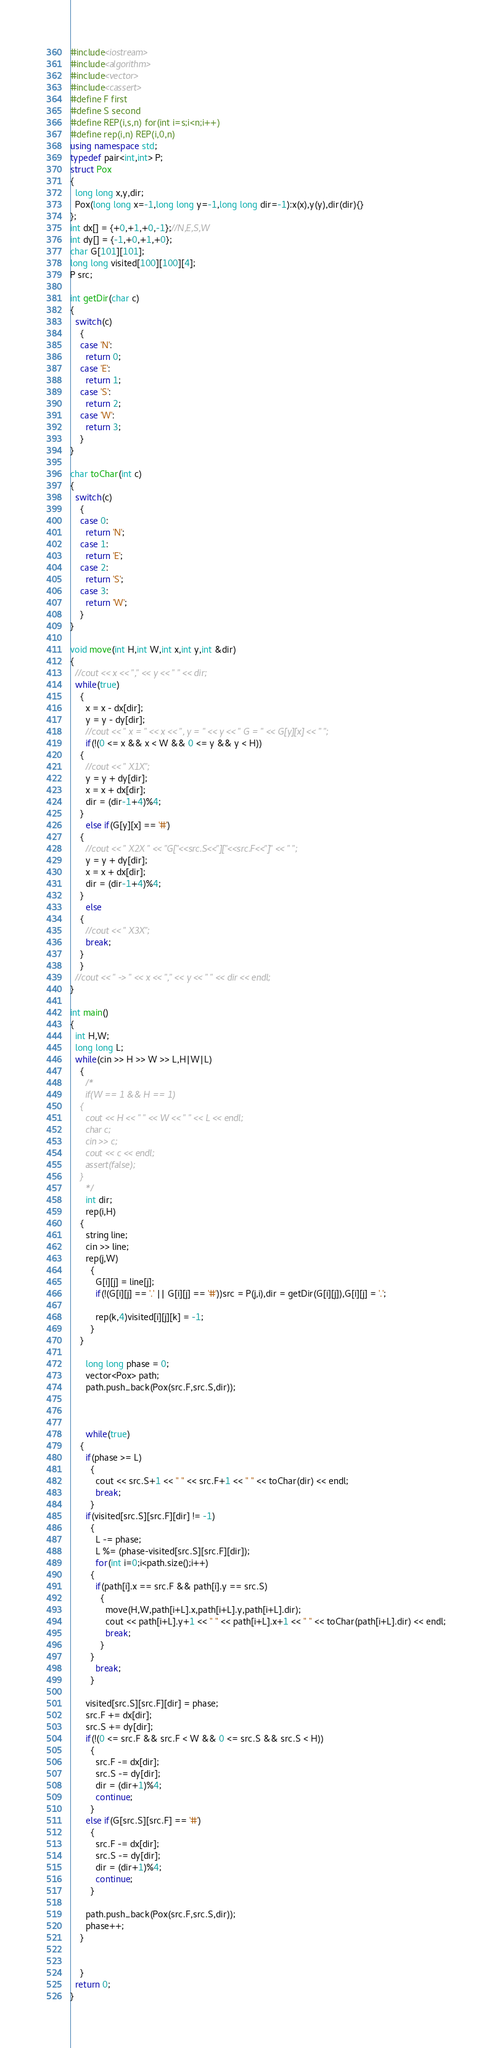Convert code to text. <code><loc_0><loc_0><loc_500><loc_500><_C++_>#include<iostream>
#include<algorithm>
#include<vector>
#include<cassert>
#define F first
#define S second
#define REP(i,s,n) for(int i=s;i<n;i++)
#define rep(i,n) REP(i,0,n)
using namespace std;
typedef pair<int,int> P;
struct Pox
{
  long long x,y,dir;
  Pox(long long x=-1,long long y=-1,long long dir=-1):x(x),y(y),dir(dir){}
};
int dx[] = {+0,+1,+0,-1};//N,E,S,W
int dy[] = {-1,+0,+1,+0};
char G[101][101];
long long visited[100][100][4];
P src;

int getDir(char c)
{
  switch(c)
    {
    case 'N':
      return 0;
    case 'E':
      return 1;
    case 'S':
      return 2;
    case 'W':
      return 3;
    }
}

char toChar(int c)
{
  switch(c)
    {
    case 0:
      return 'N';
    case 1:
      return 'E';
    case 2:
      return 'S';
    case 3:
      return 'W';
    }
}

void move(int H,int W,int x,int y,int &dir)
{
  //cout << x << "," << y << " " << dir;
  while(true)		
    {      
      x = x - dx[dir];
      y = y - dy[dir];
      //cout << " x = " << x << ", y = " << y << " G = " << G[y][x] << " ";
      if(!(0 <= x && x < W && 0 <= y && y < H))
	{
	  //cout << " X1X";
	  y = y + dy[dir];
	  x = x + dx[dir];
	  dir = (dir-1+4)%4;
	}
      else if(G[y][x] == '#')
	{
	  //cout << " X2X " << "G["<<src.S<<"]["<<src.F<<"]" << " ";
	  y = y + dy[dir];
	  x = x + dx[dir];
	  dir = (dir-1+4)%4;
	}
      else 
	{
	  //cout << " X3X";
	  break;
	}
    }
  //cout << " -> " << x << "," << y << " " << dir << endl;
}
 
int main()
{
  int H,W;
  long long L;
  while(cin >> H >> W >> L,H|W|L)
    {
      /*
      if(W == 1 && H == 1)
	{
	  cout << H << " " << W << " " << L << endl;
	  char c;
	  cin >> c;
	  cout << c << endl;
	  assert(false);
	}
      */
      int dir;
      rep(i,H)
	{
	  string line;
	  cin >> line;
	  rep(j,W)
	    {
	      G[i][j] = line[j];
	      if(!(G[i][j] == '.' || G[i][j] == '#'))src = P(j,i),dir = getDir(G[i][j]),G[i][j] = '.';
	      
	      rep(k,4)visited[i][j][k] = -1;
	    }
	}     

      long long phase = 0;
      vector<Pox> path;
      path.push_back(Pox(src.F,src.S,dir));
      


      while(true)
	{
	  if(phase >= L)
	    {
	      cout << src.S+1 << " " << src.F+1 << " " << toChar(dir) << endl;  
	      break;
	    }
	  if(visited[src.S][src.F][dir] != -1)
	    {   
	      L -= phase;
	      L %= (phase-visited[src.S][src.F][dir]);
	      for(int i=0;i<path.size();i++)
		{
		  if(path[i].x == src.F && path[i].y == src.S)
		    {
		      move(H,W,path[i+L].x,path[i+L].y,path[i+L].dir);
		      cout << path[i+L].y+1 << " " << path[i+L].x+1 << " " << toChar(path[i+L].dir) << endl;  
		      break;
		    }
		}
	      break;
	    }     
 
	  visited[src.S][src.F][dir] = phase;
	  src.F += dx[dir];
	  src.S += dy[dir];
	  if(!(0 <= src.F && src.F < W && 0 <= src.S && src.S < H))
	    {
	      src.F -= dx[dir];
	      src.S -= dy[dir];
	      dir = (dir+1)%4;
	      continue;
	    }
	  else if(G[src.S][src.F] == '#')
	    {
	      src.F -= dx[dir];
	      src.S -= dy[dir];
	      dir = (dir+1)%4;
	      continue;
	    }
 
	  path.push_back(Pox(src.F,src.S,dir));
	  phase++;
	}
      

    }
  return 0;
}</code> 